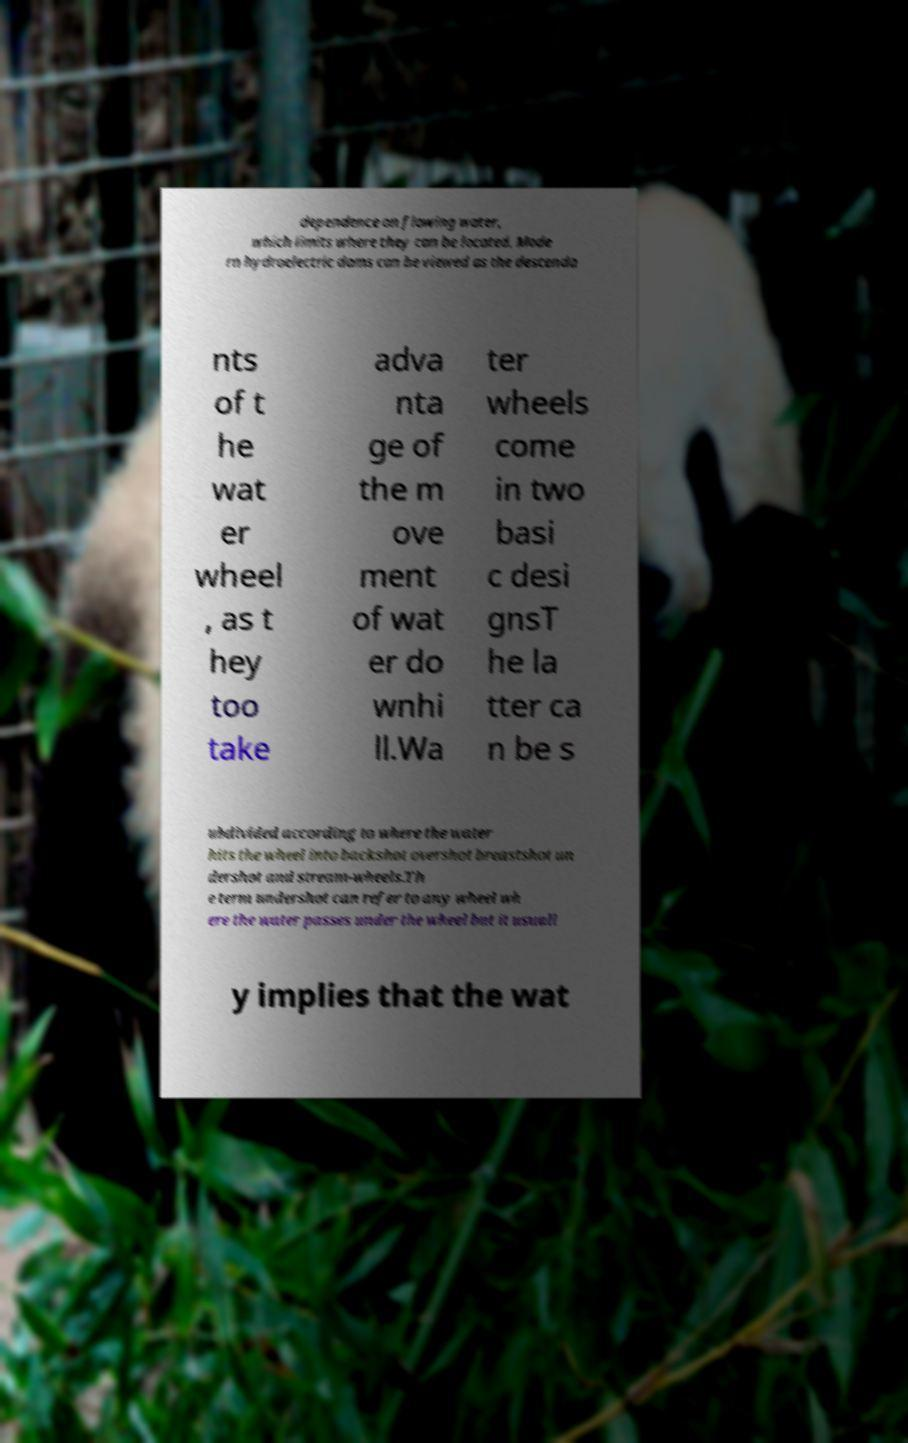Please read and relay the text visible in this image. What does it say? dependence on flowing water, which limits where they can be located. Mode rn hydroelectric dams can be viewed as the descenda nts of t he wat er wheel , as t hey too take adva nta ge of the m ove ment of wat er do wnhi ll.Wa ter wheels come in two basi c desi gnsT he la tter ca n be s ubdivided according to where the water hits the wheel into backshot overshot breastshot un dershot and stream-wheels.Th e term undershot can refer to any wheel wh ere the water passes under the wheel but it usuall y implies that the wat 